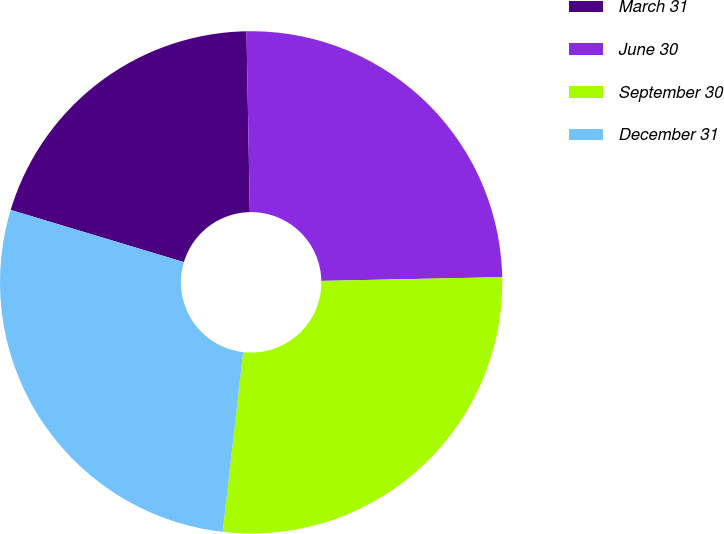Convert chart to OTSL. <chart><loc_0><loc_0><loc_500><loc_500><pie_chart><fcel>March 31<fcel>June 30<fcel>September 30<fcel>December 31<nl><fcel>20.05%<fcel>24.97%<fcel>27.14%<fcel>27.85%<nl></chart> 